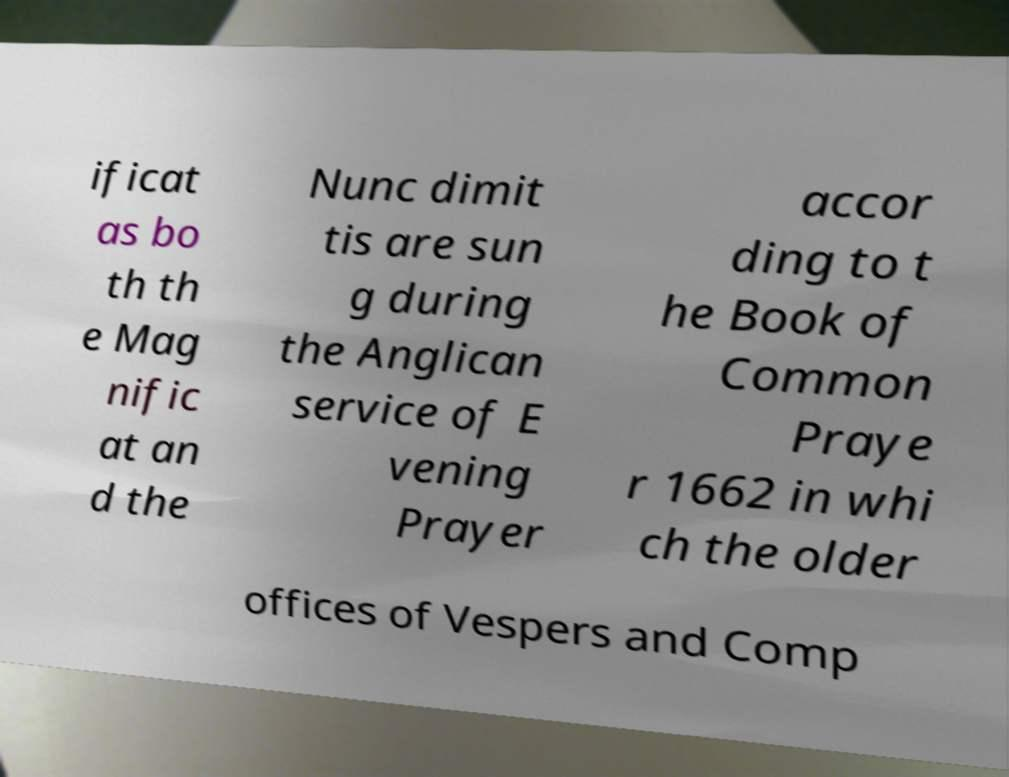I need the written content from this picture converted into text. Can you do that? ificat as bo th th e Mag nific at an d the Nunc dimit tis are sun g during the Anglican service of E vening Prayer accor ding to t he Book of Common Praye r 1662 in whi ch the older offices of Vespers and Comp 